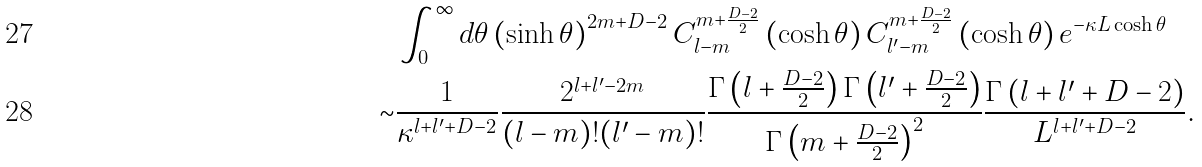Convert formula to latex. <formula><loc_0><loc_0><loc_500><loc_500>& \int _ { 0 } ^ { \infty } d \theta \left ( \sinh \theta \right ) ^ { 2 m + D - 2 } C _ { l - m } ^ { m + \frac { D - 2 } { 2 } } \left ( \cosh \theta \right ) C _ { l ^ { \prime } - m } ^ { m + \frac { D - 2 } { 2 } } \left ( \cosh \theta \right ) e ^ { - \kappa L \cosh \theta } \\ \sim & \frac { 1 } { \kappa ^ { l + l ^ { \prime } + D - 2 } } \frac { 2 ^ { l + l ^ { \prime } - 2 m } } { ( l - m ) ! ( l ^ { \prime } - m ) ! } \frac { \Gamma \left ( l + \frac { D - 2 } { 2 } \right ) \Gamma \left ( l ^ { \prime } + \frac { D - 2 } { 2 } \right ) } { \Gamma \left ( m + \frac { D - 2 } { 2 } \right ) ^ { 2 } } \frac { \Gamma \left ( l + l ^ { \prime } + D - 2 \right ) } { L ^ { l + l ^ { \prime } + D - 2 } } .</formula> 